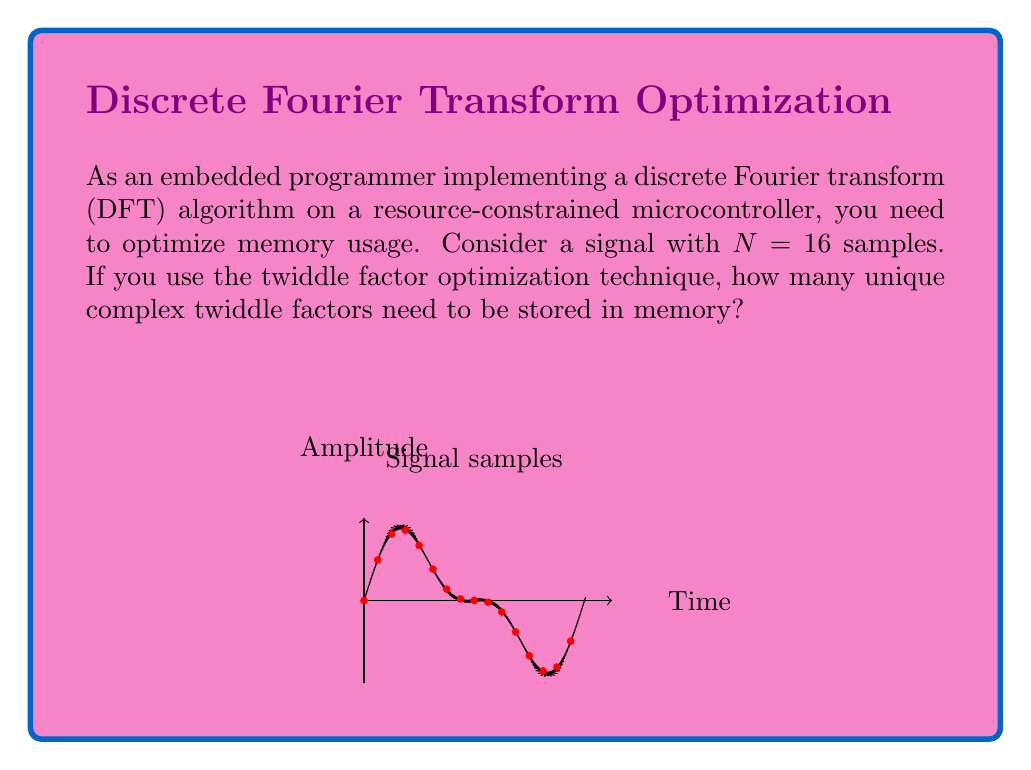Provide a solution to this math problem. Let's approach this step-by-step:

1) The twiddle factors in a DFT are given by:

   $$W_N^k = e^{-j2\pi k/N}$$

   where $N$ is the number of samples and $k$ is the index.

2) For $N = 16$, the twiddle factors are:

   $$W_{16}^k = e^{-j2\pi k/16}$$

3) Normally, we would need to calculate this for all $k$ from 0 to 15. However, we can optimize this:

4) First, note that $W_{16}^0 = 1$, which is trivial and doesn't need to be stored.

5) Next, observe the symmetry properties:
   
   $$W_{16}^k = -W_{16}^{k+8}$$
   $$W_{16}^k = (W_{16}^{k\bmod 4})^{k/4}$$

6) Due to these properties, we only need to store the twiddle factors for $k = 1, 2, 3, 4$.

7) All other twiddle factors can be derived from these four using negation, conjugation, or multiplication.

Therefore, we only need to store 4 unique complex twiddle factors in memory.
Answer: 4 complex twiddle factors 